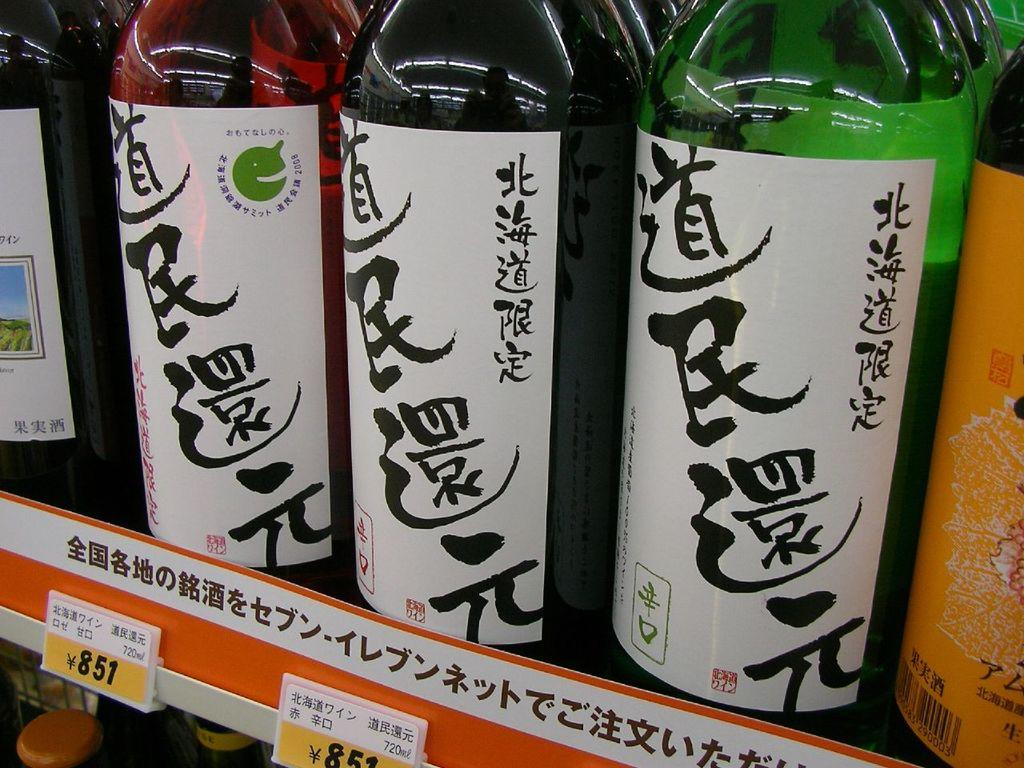What objects are present in the image? There are bottles in the image. How are the bottles being emphasized in the image? The bottles are highlighted in the image. What decorative elements are present on the bottles? There are stickers on the bottles. What type of word can be seen written on the wing of the airplane in the image? There is no airplane or wing present in the image; it only features bottles with stickers on them. 